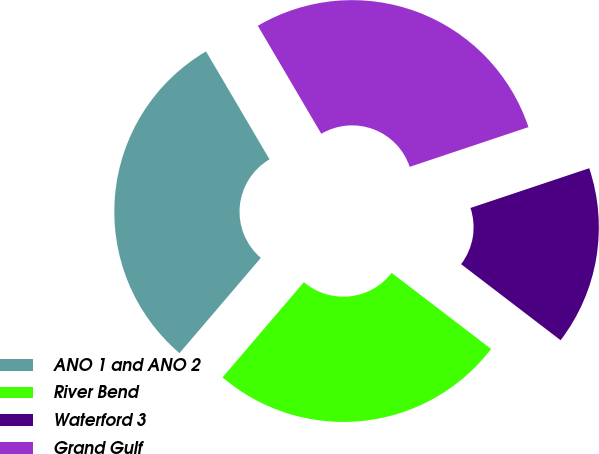<chart> <loc_0><loc_0><loc_500><loc_500><pie_chart><fcel>ANO 1 and ANO 2<fcel>River Bend<fcel>Waterford 3<fcel>Grand Gulf<nl><fcel>30.29%<fcel>25.86%<fcel>15.53%<fcel>28.32%<nl></chart> 